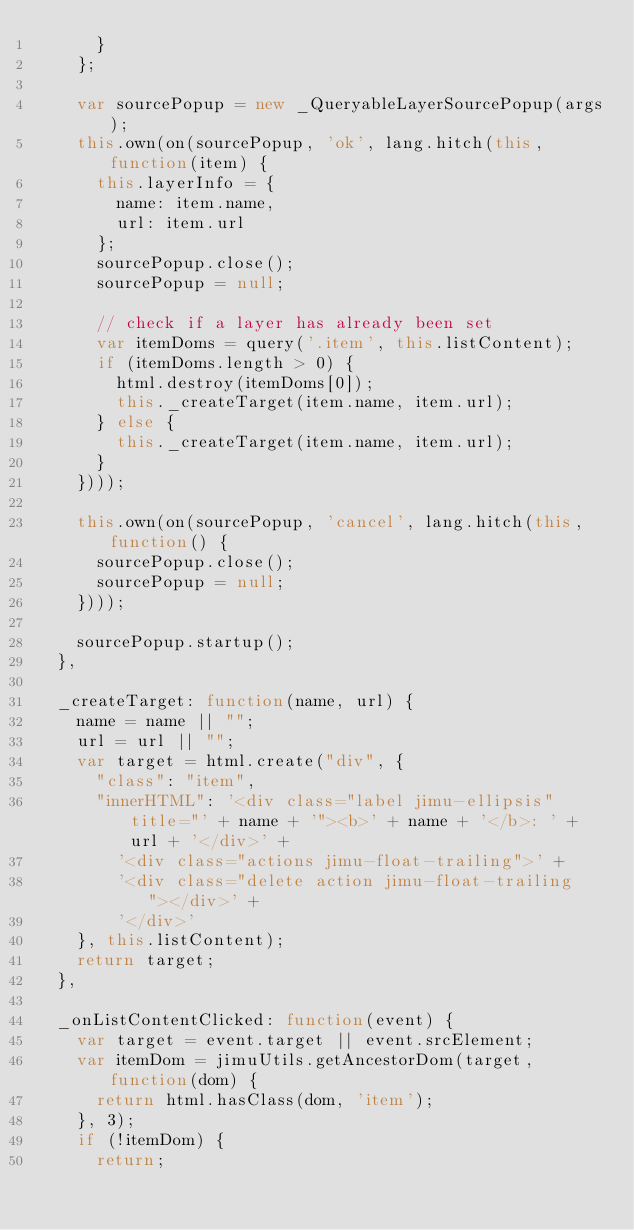Convert code to text. <code><loc_0><loc_0><loc_500><loc_500><_JavaScript_>      }
    };

    var sourcePopup = new _QueryableLayerSourcePopup(args);
    this.own(on(sourcePopup, 'ok', lang.hitch(this, function(item) {
      this.layerInfo = {
        name: item.name,
        url: item.url
      };
      sourcePopup.close();
      sourcePopup = null;

      // check if a layer has already been set
      var itemDoms = query('.item', this.listContent);
      if (itemDoms.length > 0) {
        html.destroy(itemDoms[0]);
        this._createTarget(item.name, item.url);
      } else {
        this._createTarget(item.name, item.url);
      }
    })));

    this.own(on(sourcePopup, 'cancel', lang.hitch(this, function() {
      sourcePopup.close();
      sourcePopup = null;
    })));

    sourcePopup.startup();
  },

  _createTarget: function(name, url) {
    name = name || "";
    url = url || "";
    var target = html.create("div", {
      "class": "item",
      "innerHTML": '<div class="label jimu-ellipsis" title="' + name + '"><b>' + name + '</b>: ' + url + '</div>' +
        '<div class="actions jimu-float-trailing">' +
        '<div class="delete action jimu-float-trailing"></div>' +
        '</div>'
    }, this.listContent);
    return target;
  },

  _onListContentClicked: function(event) {
    var target = event.target || event.srcElement;
    var itemDom = jimuUtils.getAncestorDom(target, function(dom) {
      return html.hasClass(dom, 'item');
    }, 3);
    if (!itemDom) {
      return;</code> 